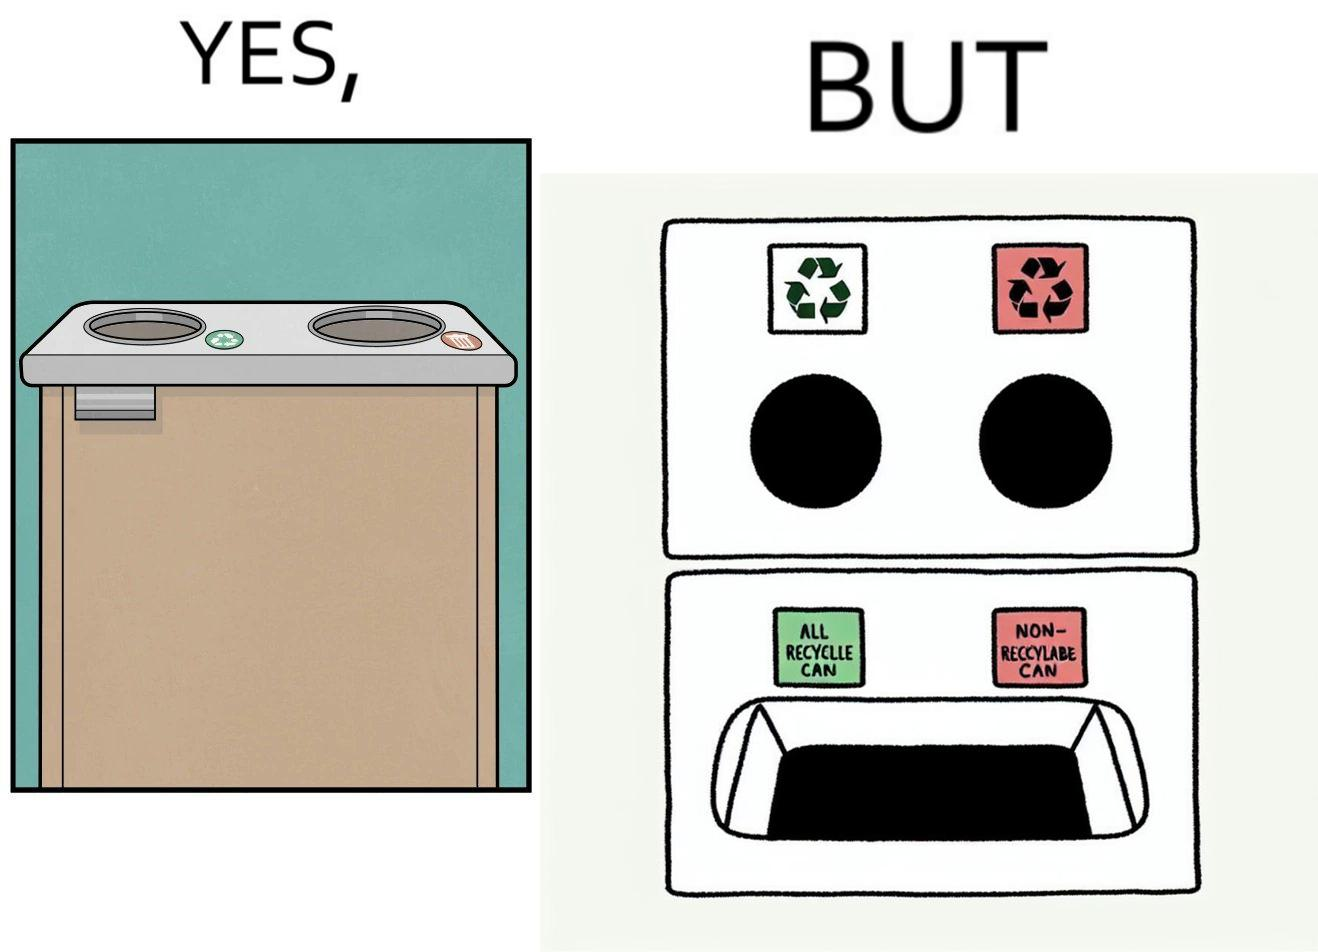What do you see in each half of this image? In the left part of the image: The image shows a garbage collection box with two holes. The hole with the green recycling sign next to it says indicates that all recyclable materials should be thrown into that hole. The hole with a red trash can lable next to it means that all other i.e non recyclable waste should be thrown into this hole. There also is a handle on the front of the box. In the right part of the image: The image shows that there is only one common bin below the holes. The hole with the green recycling sign next to it says indicates that all recyclable materials should be thrown into that hole. The hole with a red trash can lable next to it means that all other i.e non recyclable waste should be thrown into this hole. But since there is only one common bin collecti whatever is thrown through these holes, there is no separation. 